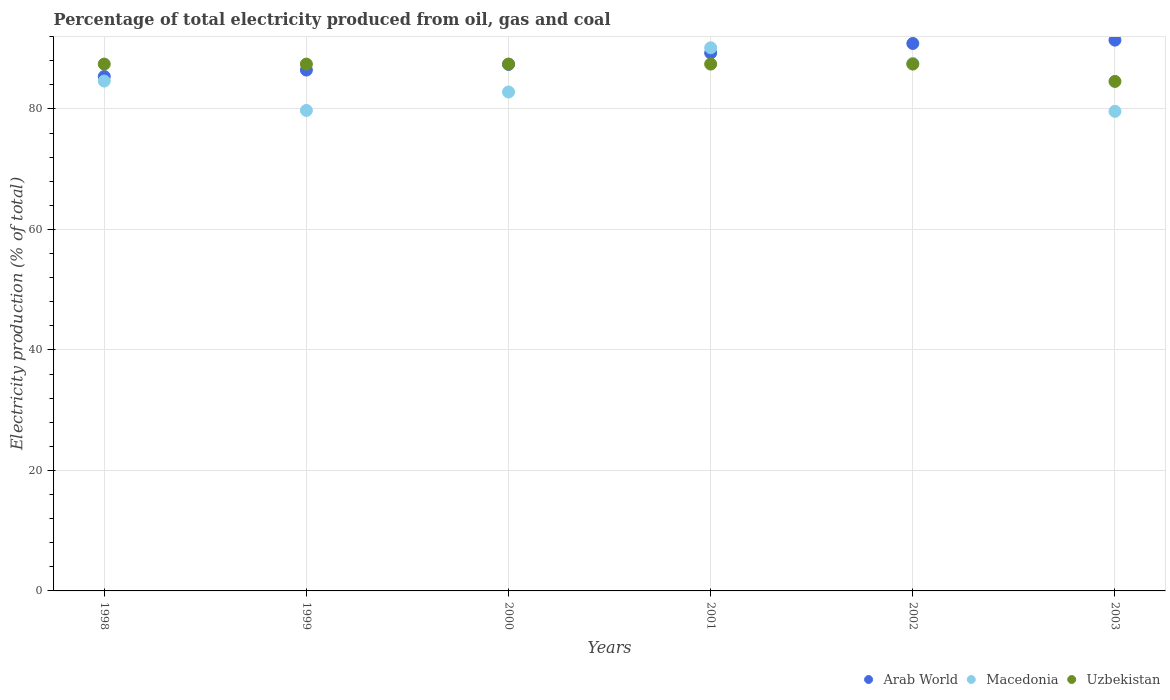How many different coloured dotlines are there?
Offer a terse response. 3. Is the number of dotlines equal to the number of legend labels?
Ensure brevity in your answer.  Yes. What is the electricity production in in Macedonia in 2003?
Ensure brevity in your answer.  79.61. Across all years, what is the maximum electricity production in in Macedonia?
Give a very brief answer. 90.16. Across all years, what is the minimum electricity production in in Uzbekistan?
Offer a very short reply. 84.57. In which year was the electricity production in in Arab World minimum?
Give a very brief answer. 1998. What is the total electricity production in in Macedonia in the graph?
Your answer should be very brief. 504.56. What is the difference between the electricity production in in Macedonia in 1999 and that in 2002?
Give a very brief answer. -7.81. What is the difference between the electricity production in in Macedonia in 2003 and the electricity production in in Uzbekistan in 2000?
Your response must be concise. -7.85. What is the average electricity production in in Arab World per year?
Offer a terse response. 88.48. In the year 2001, what is the difference between the electricity production in in Uzbekistan and electricity production in in Arab World?
Ensure brevity in your answer.  -1.84. What is the ratio of the electricity production in in Arab World in 2001 to that in 2003?
Provide a short and direct response. 0.98. What is the difference between the highest and the second highest electricity production in in Uzbekistan?
Ensure brevity in your answer.  0. What is the difference between the highest and the lowest electricity production in in Uzbekistan?
Keep it short and to the point. 2.88. In how many years, is the electricity production in in Uzbekistan greater than the average electricity production in in Uzbekistan taken over all years?
Your response must be concise. 5. Is the electricity production in in Macedonia strictly greater than the electricity production in in Uzbekistan over the years?
Make the answer very short. No. Is the electricity production in in Arab World strictly less than the electricity production in in Uzbekistan over the years?
Offer a terse response. No. How many years are there in the graph?
Ensure brevity in your answer.  6. What is the difference between two consecutive major ticks on the Y-axis?
Provide a succinct answer. 20. Are the values on the major ticks of Y-axis written in scientific E-notation?
Ensure brevity in your answer.  No. Does the graph contain any zero values?
Your response must be concise. No. Does the graph contain grids?
Offer a terse response. Yes. Where does the legend appear in the graph?
Offer a very short reply. Bottom right. How many legend labels are there?
Your answer should be very brief. 3. What is the title of the graph?
Your answer should be very brief. Percentage of total electricity produced from oil, gas and coal. What is the label or title of the Y-axis?
Provide a succinct answer. Electricity production (% of total). What is the Electricity production (% of total) of Arab World in 1998?
Your answer should be compact. 85.39. What is the Electricity production (% of total) in Macedonia in 1998?
Keep it short and to the point. 84.63. What is the Electricity production (% of total) in Uzbekistan in 1998?
Provide a succinct answer. 87.46. What is the Electricity production (% of total) in Arab World in 1999?
Offer a terse response. 86.46. What is the Electricity production (% of total) in Macedonia in 1999?
Your answer should be compact. 79.76. What is the Electricity production (% of total) of Uzbekistan in 1999?
Offer a very short reply. 87.45. What is the Electricity production (% of total) of Arab World in 2000?
Keep it short and to the point. 87.4. What is the Electricity production (% of total) in Macedonia in 2000?
Your answer should be very brief. 82.82. What is the Electricity production (% of total) in Uzbekistan in 2000?
Give a very brief answer. 87.46. What is the Electricity production (% of total) of Arab World in 2001?
Ensure brevity in your answer.  89.3. What is the Electricity production (% of total) of Macedonia in 2001?
Make the answer very short. 90.16. What is the Electricity production (% of total) of Uzbekistan in 2001?
Offer a very short reply. 87.45. What is the Electricity production (% of total) in Arab World in 2002?
Offer a terse response. 90.87. What is the Electricity production (% of total) of Macedonia in 2002?
Offer a terse response. 87.57. What is the Electricity production (% of total) in Uzbekistan in 2002?
Provide a succinct answer. 87.45. What is the Electricity production (% of total) in Arab World in 2003?
Provide a short and direct response. 91.43. What is the Electricity production (% of total) of Macedonia in 2003?
Your answer should be very brief. 79.61. What is the Electricity production (% of total) of Uzbekistan in 2003?
Provide a short and direct response. 84.57. Across all years, what is the maximum Electricity production (% of total) in Arab World?
Offer a terse response. 91.43. Across all years, what is the maximum Electricity production (% of total) of Macedonia?
Offer a very short reply. 90.16. Across all years, what is the maximum Electricity production (% of total) in Uzbekistan?
Make the answer very short. 87.46. Across all years, what is the minimum Electricity production (% of total) in Arab World?
Your answer should be very brief. 85.39. Across all years, what is the minimum Electricity production (% of total) in Macedonia?
Offer a very short reply. 79.61. Across all years, what is the minimum Electricity production (% of total) of Uzbekistan?
Provide a short and direct response. 84.57. What is the total Electricity production (% of total) in Arab World in the graph?
Your answer should be very brief. 530.86. What is the total Electricity production (% of total) in Macedonia in the graph?
Provide a short and direct response. 504.56. What is the total Electricity production (% of total) of Uzbekistan in the graph?
Provide a short and direct response. 521.85. What is the difference between the Electricity production (% of total) in Arab World in 1998 and that in 1999?
Your answer should be compact. -1.07. What is the difference between the Electricity production (% of total) of Macedonia in 1998 and that in 1999?
Provide a short and direct response. 4.87. What is the difference between the Electricity production (% of total) in Arab World in 1998 and that in 2000?
Give a very brief answer. -2.01. What is the difference between the Electricity production (% of total) in Macedonia in 1998 and that in 2000?
Keep it short and to the point. 1.81. What is the difference between the Electricity production (% of total) of Arab World in 1998 and that in 2001?
Your response must be concise. -3.9. What is the difference between the Electricity production (% of total) in Macedonia in 1998 and that in 2001?
Your answer should be very brief. -5.53. What is the difference between the Electricity production (% of total) of Uzbekistan in 1998 and that in 2001?
Offer a very short reply. 0. What is the difference between the Electricity production (% of total) in Arab World in 1998 and that in 2002?
Ensure brevity in your answer.  -5.48. What is the difference between the Electricity production (% of total) of Macedonia in 1998 and that in 2002?
Your answer should be compact. -2.94. What is the difference between the Electricity production (% of total) in Uzbekistan in 1998 and that in 2002?
Your answer should be compact. 0. What is the difference between the Electricity production (% of total) of Arab World in 1998 and that in 2003?
Give a very brief answer. -6.04. What is the difference between the Electricity production (% of total) of Macedonia in 1998 and that in 2003?
Offer a very short reply. 5.03. What is the difference between the Electricity production (% of total) in Uzbekistan in 1998 and that in 2003?
Give a very brief answer. 2.88. What is the difference between the Electricity production (% of total) of Arab World in 1999 and that in 2000?
Your response must be concise. -0.94. What is the difference between the Electricity production (% of total) in Macedonia in 1999 and that in 2000?
Provide a short and direct response. -3.06. What is the difference between the Electricity production (% of total) in Uzbekistan in 1999 and that in 2000?
Provide a short and direct response. -0. What is the difference between the Electricity production (% of total) in Arab World in 1999 and that in 2001?
Offer a very short reply. -2.83. What is the difference between the Electricity production (% of total) of Macedonia in 1999 and that in 2001?
Provide a succinct answer. -10.4. What is the difference between the Electricity production (% of total) in Arab World in 1999 and that in 2002?
Make the answer very short. -4.41. What is the difference between the Electricity production (% of total) of Macedonia in 1999 and that in 2002?
Give a very brief answer. -7.81. What is the difference between the Electricity production (% of total) in Uzbekistan in 1999 and that in 2002?
Make the answer very short. -0. What is the difference between the Electricity production (% of total) of Arab World in 1999 and that in 2003?
Make the answer very short. -4.97. What is the difference between the Electricity production (% of total) in Macedonia in 1999 and that in 2003?
Provide a succinct answer. 0.15. What is the difference between the Electricity production (% of total) of Uzbekistan in 1999 and that in 2003?
Your answer should be compact. 2.88. What is the difference between the Electricity production (% of total) of Arab World in 2000 and that in 2001?
Your response must be concise. -1.9. What is the difference between the Electricity production (% of total) of Macedonia in 2000 and that in 2001?
Offer a very short reply. -7.34. What is the difference between the Electricity production (% of total) in Arab World in 2000 and that in 2002?
Provide a succinct answer. -3.47. What is the difference between the Electricity production (% of total) of Macedonia in 2000 and that in 2002?
Your response must be concise. -4.75. What is the difference between the Electricity production (% of total) in Arab World in 2000 and that in 2003?
Give a very brief answer. -4.03. What is the difference between the Electricity production (% of total) of Macedonia in 2000 and that in 2003?
Your answer should be compact. 3.21. What is the difference between the Electricity production (% of total) in Uzbekistan in 2000 and that in 2003?
Provide a succinct answer. 2.88. What is the difference between the Electricity production (% of total) of Arab World in 2001 and that in 2002?
Your answer should be very brief. -1.58. What is the difference between the Electricity production (% of total) of Macedonia in 2001 and that in 2002?
Keep it short and to the point. 2.59. What is the difference between the Electricity production (% of total) in Uzbekistan in 2001 and that in 2002?
Your response must be concise. -0. What is the difference between the Electricity production (% of total) of Arab World in 2001 and that in 2003?
Make the answer very short. -2.13. What is the difference between the Electricity production (% of total) of Macedonia in 2001 and that in 2003?
Keep it short and to the point. 10.55. What is the difference between the Electricity production (% of total) in Uzbekistan in 2001 and that in 2003?
Your answer should be very brief. 2.88. What is the difference between the Electricity production (% of total) in Arab World in 2002 and that in 2003?
Offer a terse response. -0.55. What is the difference between the Electricity production (% of total) of Macedonia in 2002 and that in 2003?
Offer a terse response. 7.96. What is the difference between the Electricity production (% of total) in Uzbekistan in 2002 and that in 2003?
Offer a terse response. 2.88. What is the difference between the Electricity production (% of total) in Arab World in 1998 and the Electricity production (% of total) in Macedonia in 1999?
Make the answer very short. 5.63. What is the difference between the Electricity production (% of total) in Arab World in 1998 and the Electricity production (% of total) in Uzbekistan in 1999?
Provide a short and direct response. -2.06. What is the difference between the Electricity production (% of total) of Macedonia in 1998 and the Electricity production (% of total) of Uzbekistan in 1999?
Your answer should be very brief. -2.82. What is the difference between the Electricity production (% of total) of Arab World in 1998 and the Electricity production (% of total) of Macedonia in 2000?
Your answer should be compact. 2.57. What is the difference between the Electricity production (% of total) of Arab World in 1998 and the Electricity production (% of total) of Uzbekistan in 2000?
Provide a short and direct response. -2.06. What is the difference between the Electricity production (% of total) in Macedonia in 1998 and the Electricity production (% of total) in Uzbekistan in 2000?
Provide a short and direct response. -2.82. What is the difference between the Electricity production (% of total) of Arab World in 1998 and the Electricity production (% of total) of Macedonia in 2001?
Give a very brief answer. -4.77. What is the difference between the Electricity production (% of total) of Arab World in 1998 and the Electricity production (% of total) of Uzbekistan in 2001?
Offer a very short reply. -2.06. What is the difference between the Electricity production (% of total) in Macedonia in 1998 and the Electricity production (% of total) in Uzbekistan in 2001?
Provide a succinct answer. -2.82. What is the difference between the Electricity production (% of total) in Arab World in 1998 and the Electricity production (% of total) in Macedonia in 2002?
Provide a succinct answer. -2.18. What is the difference between the Electricity production (% of total) in Arab World in 1998 and the Electricity production (% of total) in Uzbekistan in 2002?
Provide a short and direct response. -2.06. What is the difference between the Electricity production (% of total) in Macedonia in 1998 and the Electricity production (% of total) in Uzbekistan in 2002?
Provide a succinct answer. -2.82. What is the difference between the Electricity production (% of total) of Arab World in 1998 and the Electricity production (% of total) of Macedonia in 2003?
Provide a short and direct response. 5.79. What is the difference between the Electricity production (% of total) of Arab World in 1998 and the Electricity production (% of total) of Uzbekistan in 2003?
Your response must be concise. 0.82. What is the difference between the Electricity production (% of total) of Macedonia in 1998 and the Electricity production (% of total) of Uzbekistan in 2003?
Your response must be concise. 0.06. What is the difference between the Electricity production (% of total) in Arab World in 1999 and the Electricity production (% of total) in Macedonia in 2000?
Give a very brief answer. 3.64. What is the difference between the Electricity production (% of total) of Arab World in 1999 and the Electricity production (% of total) of Uzbekistan in 2000?
Give a very brief answer. -0.99. What is the difference between the Electricity production (% of total) in Macedonia in 1999 and the Electricity production (% of total) in Uzbekistan in 2000?
Make the answer very short. -7.69. What is the difference between the Electricity production (% of total) in Arab World in 1999 and the Electricity production (% of total) in Macedonia in 2001?
Keep it short and to the point. -3.7. What is the difference between the Electricity production (% of total) of Arab World in 1999 and the Electricity production (% of total) of Uzbekistan in 2001?
Offer a very short reply. -0.99. What is the difference between the Electricity production (% of total) in Macedonia in 1999 and the Electricity production (% of total) in Uzbekistan in 2001?
Ensure brevity in your answer.  -7.69. What is the difference between the Electricity production (% of total) in Arab World in 1999 and the Electricity production (% of total) in Macedonia in 2002?
Provide a short and direct response. -1.11. What is the difference between the Electricity production (% of total) in Arab World in 1999 and the Electricity production (% of total) in Uzbekistan in 2002?
Keep it short and to the point. -0.99. What is the difference between the Electricity production (% of total) in Macedonia in 1999 and the Electricity production (% of total) in Uzbekistan in 2002?
Keep it short and to the point. -7.69. What is the difference between the Electricity production (% of total) in Arab World in 1999 and the Electricity production (% of total) in Macedonia in 2003?
Ensure brevity in your answer.  6.85. What is the difference between the Electricity production (% of total) of Arab World in 1999 and the Electricity production (% of total) of Uzbekistan in 2003?
Offer a terse response. 1.89. What is the difference between the Electricity production (% of total) in Macedonia in 1999 and the Electricity production (% of total) in Uzbekistan in 2003?
Provide a short and direct response. -4.81. What is the difference between the Electricity production (% of total) of Arab World in 2000 and the Electricity production (% of total) of Macedonia in 2001?
Ensure brevity in your answer.  -2.76. What is the difference between the Electricity production (% of total) of Arab World in 2000 and the Electricity production (% of total) of Uzbekistan in 2001?
Make the answer very short. -0.05. What is the difference between the Electricity production (% of total) of Macedonia in 2000 and the Electricity production (% of total) of Uzbekistan in 2001?
Provide a short and direct response. -4.63. What is the difference between the Electricity production (% of total) of Arab World in 2000 and the Electricity production (% of total) of Macedonia in 2002?
Your response must be concise. -0.17. What is the difference between the Electricity production (% of total) of Arab World in 2000 and the Electricity production (% of total) of Uzbekistan in 2002?
Give a very brief answer. -0.05. What is the difference between the Electricity production (% of total) of Macedonia in 2000 and the Electricity production (% of total) of Uzbekistan in 2002?
Provide a short and direct response. -4.63. What is the difference between the Electricity production (% of total) in Arab World in 2000 and the Electricity production (% of total) in Macedonia in 2003?
Make the answer very short. 7.79. What is the difference between the Electricity production (% of total) in Arab World in 2000 and the Electricity production (% of total) in Uzbekistan in 2003?
Provide a succinct answer. 2.83. What is the difference between the Electricity production (% of total) of Macedonia in 2000 and the Electricity production (% of total) of Uzbekistan in 2003?
Offer a terse response. -1.75. What is the difference between the Electricity production (% of total) of Arab World in 2001 and the Electricity production (% of total) of Macedonia in 2002?
Your response must be concise. 1.72. What is the difference between the Electricity production (% of total) of Arab World in 2001 and the Electricity production (% of total) of Uzbekistan in 2002?
Make the answer very short. 1.84. What is the difference between the Electricity production (% of total) in Macedonia in 2001 and the Electricity production (% of total) in Uzbekistan in 2002?
Make the answer very short. 2.71. What is the difference between the Electricity production (% of total) in Arab World in 2001 and the Electricity production (% of total) in Macedonia in 2003?
Offer a very short reply. 9.69. What is the difference between the Electricity production (% of total) of Arab World in 2001 and the Electricity production (% of total) of Uzbekistan in 2003?
Give a very brief answer. 4.72. What is the difference between the Electricity production (% of total) in Macedonia in 2001 and the Electricity production (% of total) in Uzbekistan in 2003?
Keep it short and to the point. 5.59. What is the difference between the Electricity production (% of total) of Arab World in 2002 and the Electricity production (% of total) of Macedonia in 2003?
Ensure brevity in your answer.  11.27. What is the difference between the Electricity production (% of total) of Macedonia in 2002 and the Electricity production (% of total) of Uzbekistan in 2003?
Offer a very short reply. 3. What is the average Electricity production (% of total) of Arab World per year?
Keep it short and to the point. 88.48. What is the average Electricity production (% of total) of Macedonia per year?
Give a very brief answer. 84.09. What is the average Electricity production (% of total) of Uzbekistan per year?
Offer a very short reply. 86.97. In the year 1998, what is the difference between the Electricity production (% of total) of Arab World and Electricity production (% of total) of Macedonia?
Your response must be concise. 0.76. In the year 1998, what is the difference between the Electricity production (% of total) in Arab World and Electricity production (% of total) in Uzbekistan?
Ensure brevity in your answer.  -2.06. In the year 1998, what is the difference between the Electricity production (% of total) in Macedonia and Electricity production (% of total) in Uzbekistan?
Your answer should be very brief. -2.82. In the year 1999, what is the difference between the Electricity production (% of total) in Arab World and Electricity production (% of total) in Macedonia?
Give a very brief answer. 6.7. In the year 1999, what is the difference between the Electricity production (% of total) of Arab World and Electricity production (% of total) of Uzbekistan?
Your answer should be compact. -0.99. In the year 1999, what is the difference between the Electricity production (% of total) of Macedonia and Electricity production (% of total) of Uzbekistan?
Your response must be concise. -7.69. In the year 2000, what is the difference between the Electricity production (% of total) in Arab World and Electricity production (% of total) in Macedonia?
Your answer should be very brief. 4.58. In the year 2000, what is the difference between the Electricity production (% of total) in Arab World and Electricity production (% of total) in Uzbekistan?
Give a very brief answer. -0.05. In the year 2000, what is the difference between the Electricity production (% of total) in Macedonia and Electricity production (% of total) in Uzbekistan?
Offer a terse response. -4.63. In the year 2001, what is the difference between the Electricity production (% of total) in Arab World and Electricity production (% of total) in Macedonia?
Offer a terse response. -0.86. In the year 2001, what is the difference between the Electricity production (% of total) in Arab World and Electricity production (% of total) in Uzbekistan?
Your answer should be very brief. 1.84. In the year 2001, what is the difference between the Electricity production (% of total) of Macedonia and Electricity production (% of total) of Uzbekistan?
Offer a terse response. 2.71. In the year 2002, what is the difference between the Electricity production (% of total) in Arab World and Electricity production (% of total) in Macedonia?
Give a very brief answer. 3.3. In the year 2002, what is the difference between the Electricity production (% of total) in Arab World and Electricity production (% of total) in Uzbekistan?
Keep it short and to the point. 3.42. In the year 2002, what is the difference between the Electricity production (% of total) in Macedonia and Electricity production (% of total) in Uzbekistan?
Offer a terse response. 0.12. In the year 2003, what is the difference between the Electricity production (% of total) in Arab World and Electricity production (% of total) in Macedonia?
Your response must be concise. 11.82. In the year 2003, what is the difference between the Electricity production (% of total) in Arab World and Electricity production (% of total) in Uzbekistan?
Keep it short and to the point. 6.85. In the year 2003, what is the difference between the Electricity production (% of total) of Macedonia and Electricity production (% of total) of Uzbekistan?
Provide a short and direct response. -4.97. What is the ratio of the Electricity production (% of total) of Arab World in 1998 to that in 1999?
Keep it short and to the point. 0.99. What is the ratio of the Electricity production (% of total) of Macedonia in 1998 to that in 1999?
Ensure brevity in your answer.  1.06. What is the ratio of the Electricity production (% of total) of Macedonia in 1998 to that in 2000?
Keep it short and to the point. 1.02. What is the ratio of the Electricity production (% of total) in Arab World in 1998 to that in 2001?
Give a very brief answer. 0.96. What is the ratio of the Electricity production (% of total) of Macedonia in 1998 to that in 2001?
Offer a very short reply. 0.94. What is the ratio of the Electricity production (% of total) in Uzbekistan in 1998 to that in 2001?
Provide a succinct answer. 1. What is the ratio of the Electricity production (% of total) in Arab World in 1998 to that in 2002?
Your answer should be very brief. 0.94. What is the ratio of the Electricity production (% of total) in Macedonia in 1998 to that in 2002?
Ensure brevity in your answer.  0.97. What is the ratio of the Electricity production (% of total) in Arab World in 1998 to that in 2003?
Your answer should be very brief. 0.93. What is the ratio of the Electricity production (% of total) in Macedonia in 1998 to that in 2003?
Offer a terse response. 1.06. What is the ratio of the Electricity production (% of total) of Uzbekistan in 1998 to that in 2003?
Provide a succinct answer. 1.03. What is the ratio of the Electricity production (% of total) of Arab World in 1999 to that in 2000?
Provide a succinct answer. 0.99. What is the ratio of the Electricity production (% of total) in Uzbekistan in 1999 to that in 2000?
Offer a very short reply. 1. What is the ratio of the Electricity production (% of total) in Arab World in 1999 to that in 2001?
Provide a short and direct response. 0.97. What is the ratio of the Electricity production (% of total) in Macedonia in 1999 to that in 2001?
Your response must be concise. 0.88. What is the ratio of the Electricity production (% of total) of Uzbekistan in 1999 to that in 2001?
Your answer should be very brief. 1. What is the ratio of the Electricity production (% of total) of Arab World in 1999 to that in 2002?
Offer a very short reply. 0.95. What is the ratio of the Electricity production (% of total) of Macedonia in 1999 to that in 2002?
Provide a short and direct response. 0.91. What is the ratio of the Electricity production (% of total) in Uzbekistan in 1999 to that in 2002?
Offer a terse response. 1. What is the ratio of the Electricity production (% of total) of Arab World in 1999 to that in 2003?
Offer a terse response. 0.95. What is the ratio of the Electricity production (% of total) of Uzbekistan in 1999 to that in 2003?
Ensure brevity in your answer.  1.03. What is the ratio of the Electricity production (% of total) in Arab World in 2000 to that in 2001?
Your answer should be very brief. 0.98. What is the ratio of the Electricity production (% of total) of Macedonia in 2000 to that in 2001?
Make the answer very short. 0.92. What is the ratio of the Electricity production (% of total) of Uzbekistan in 2000 to that in 2001?
Provide a succinct answer. 1. What is the ratio of the Electricity production (% of total) in Arab World in 2000 to that in 2002?
Give a very brief answer. 0.96. What is the ratio of the Electricity production (% of total) in Macedonia in 2000 to that in 2002?
Provide a short and direct response. 0.95. What is the ratio of the Electricity production (% of total) in Arab World in 2000 to that in 2003?
Offer a terse response. 0.96. What is the ratio of the Electricity production (% of total) of Macedonia in 2000 to that in 2003?
Offer a very short reply. 1.04. What is the ratio of the Electricity production (% of total) of Uzbekistan in 2000 to that in 2003?
Offer a terse response. 1.03. What is the ratio of the Electricity production (% of total) of Arab World in 2001 to that in 2002?
Provide a succinct answer. 0.98. What is the ratio of the Electricity production (% of total) of Macedonia in 2001 to that in 2002?
Provide a succinct answer. 1.03. What is the ratio of the Electricity production (% of total) of Arab World in 2001 to that in 2003?
Offer a terse response. 0.98. What is the ratio of the Electricity production (% of total) in Macedonia in 2001 to that in 2003?
Your answer should be very brief. 1.13. What is the ratio of the Electricity production (% of total) of Uzbekistan in 2001 to that in 2003?
Provide a short and direct response. 1.03. What is the ratio of the Electricity production (% of total) of Arab World in 2002 to that in 2003?
Ensure brevity in your answer.  0.99. What is the ratio of the Electricity production (% of total) of Macedonia in 2002 to that in 2003?
Ensure brevity in your answer.  1.1. What is the ratio of the Electricity production (% of total) in Uzbekistan in 2002 to that in 2003?
Offer a terse response. 1.03. What is the difference between the highest and the second highest Electricity production (% of total) in Arab World?
Keep it short and to the point. 0.55. What is the difference between the highest and the second highest Electricity production (% of total) of Macedonia?
Offer a terse response. 2.59. What is the difference between the highest and the second highest Electricity production (% of total) in Uzbekistan?
Offer a very short reply. 0. What is the difference between the highest and the lowest Electricity production (% of total) in Arab World?
Your answer should be compact. 6.04. What is the difference between the highest and the lowest Electricity production (% of total) of Macedonia?
Offer a terse response. 10.55. What is the difference between the highest and the lowest Electricity production (% of total) of Uzbekistan?
Your response must be concise. 2.88. 